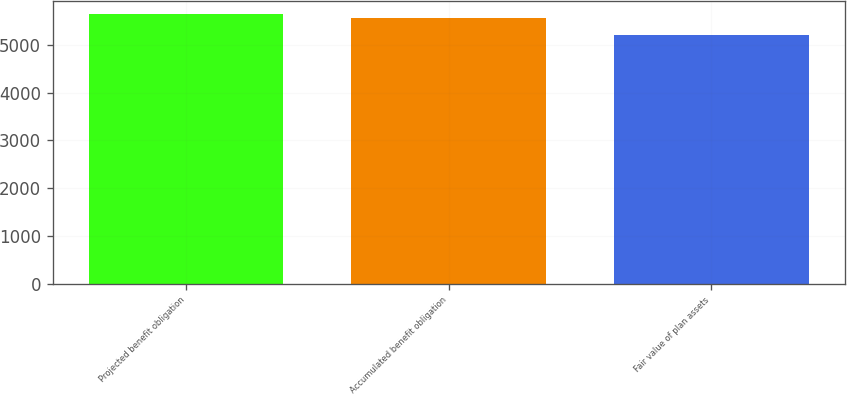Convert chart. <chart><loc_0><loc_0><loc_500><loc_500><bar_chart><fcel>Projected benefit obligation<fcel>Accumulated benefit obligation<fcel>Fair value of plan assets<nl><fcel>5640<fcel>5555<fcel>5205<nl></chart> 